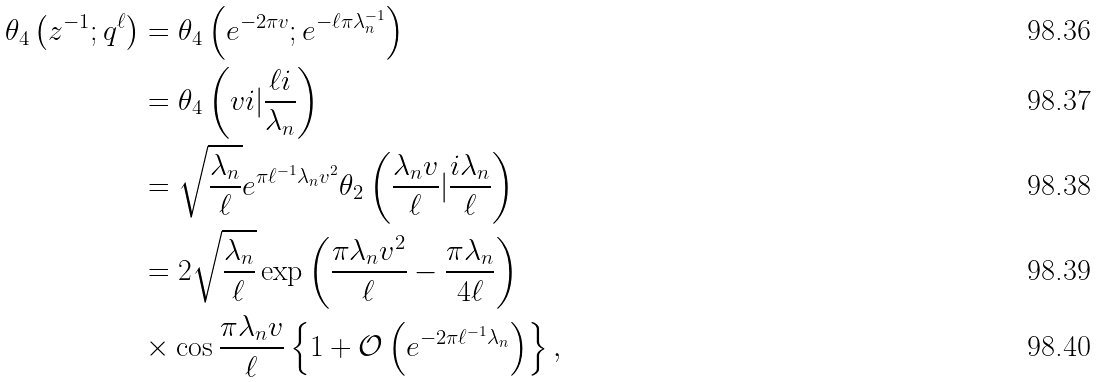<formula> <loc_0><loc_0><loc_500><loc_500>\theta _ { 4 } \left ( z ^ { - 1 } ; q ^ { \ell } \right ) & = \theta _ { 4 } \left ( e ^ { - 2 \pi v } ; e ^ { - \ell \pi \lambda _ { n } ^ { - 1 } } \right ) \\ & = \theta _ { 4 } \left ( v i | \frac { \ell i } { \lambda _ { n } } \right ) \\ & = \sqrt { \frac { \lambda _ { n } } { \ell } } e ^ { \pi \ell ^ { - 1 } \lambda _ { n } v ^ { 2 } } \theta _ { 2 } \left ( \frac { \lambda _ { n } v } { \ell } | \frac { i \lambda _ { n } } { \ell } \right ) \\ & = 2 \sqrt { \frac { \lambda _ { n } } { \ell } } \exp \left ( \frac { \pi \lambda _ { n } v ^ { 2 } } { \ell } - \frac { \pi \lambda _ { n } } { 4 \ell } \right ) \\ & \times \cos \frac { \pi \lambda _ { n } v } { \ell } \left \{ 1 + \mathcal { O } \left ( e ^ { - 2 \pi \ell ^ { - 1 } \lambda _ { n } } \right ) \right \} ,</formula> 